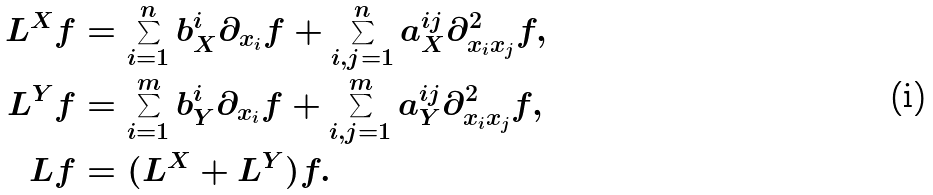Convert formula to latex. <formula><loc_0><loc_0><loc_500><loc_500>L ^ { X } f & = \sum _ { i = 1 } ^ { n } b _ { X } ^ { i } \partial _ { x _ { i } } f + \sum _ { i , j = 1 } ^ { n } a _ { X } ^ { i j } \partial _ { x _ { i } x _ { j } } ^ { 2 } f , \\ L ^ { Y } f & = \sum _ { i = 1 } ^ { m } b _ { Y } ^ { i } \partial _ { x _ { i } } f + \sum _ { i , j = 1 } ^ { m } a _ { Y } ^ { i j } \partial _ { x _ { i } x _ { j } } ^ { 2 } f , \\ L f & = ( L ^ { X } + L ^ { Y } ) f .</formula> 